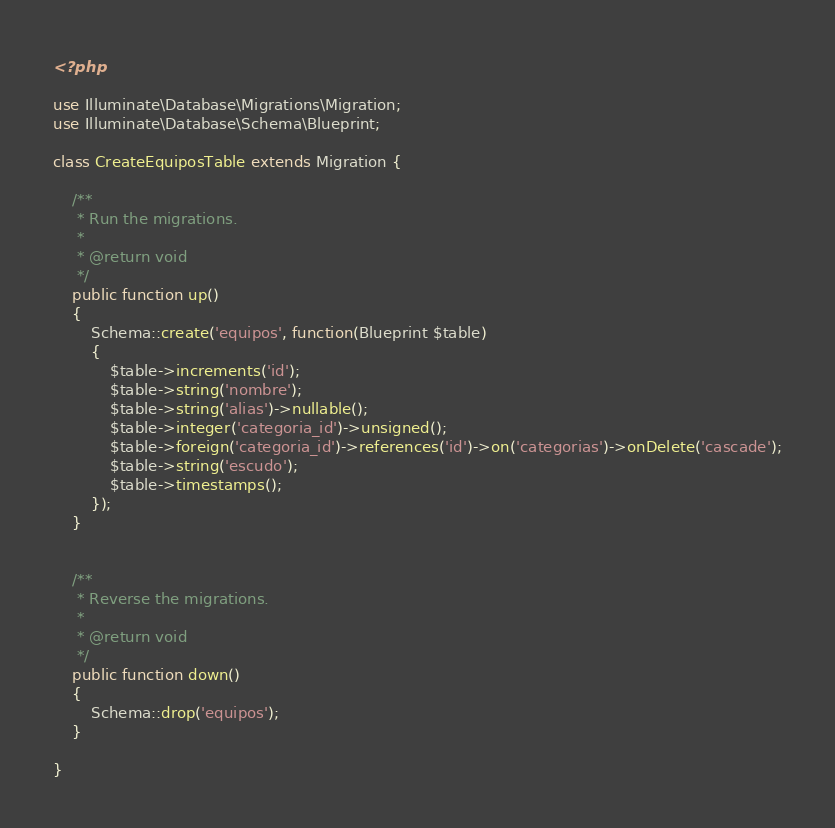Convert code to text. <code><loc_0><loc_0><loc_500><loc_500><_PHP_><?php

use Illuminate\Database\Migrations\Migration;
use Illuminate\Database\Schema\Blueprint;

class CreateEquiposTable extends Migration {

	/**
	 * Run the migrations.
	 *
	 * @return void
	 */
	public function up()
	{
		Schema::create('equipos', function(Blueprint $table)
		{
			$table->increments('id');
			$table->string('nombre');
			$table->string('alias')->nullable();
			$table->integer('categoria_id')->unsigned();
			$table->foreign('categoria_id')->references('id')->on('categorias')->onDelete('cascade');
			$table->string('escudo');
			$table->timestamps();
		});
	}


	/**
	 * Reverse the migrations.
	 *
	 * @return void
	 */
	public function down()
	{
		Schema::drop('equipos');
	}

}
</code> 